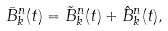<formula> <loc_0><loc_0><loc_500><loc_500>{ \bar { B } } _ { k } ^ { n } ( t ) = { \tilde { B } } _ { k } ^ { n } ( t ) + { \hat { B } } _ { k } ^ { n } ( t ) ,</formula> 